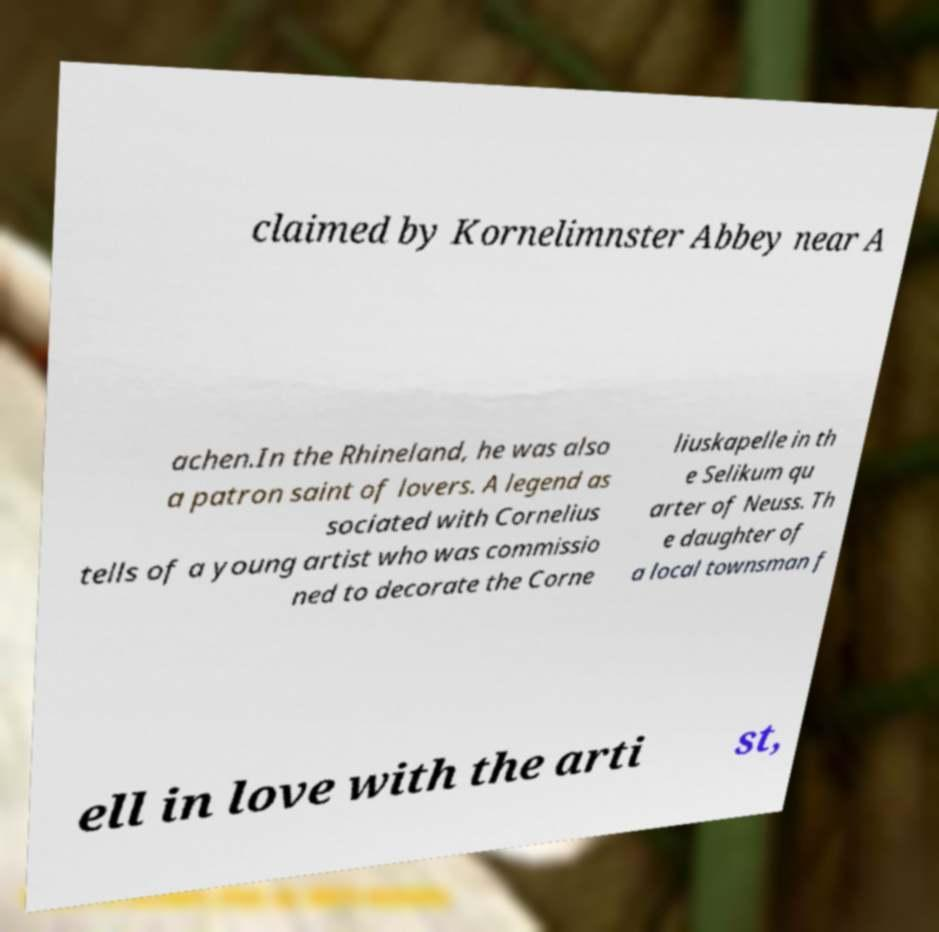I need the written content from this picture converted into text. Can you do that? claimed by Kornelimnster Abbey near A achen.In the Rhineland, he was also a patron saint of lovers. A legend as sociated with Cornelius tells of a young artist who was commissio ned to decorate the Corne liuskapelle in th e Selikum qu arter of Neuss. Th e daughter of a local townsman f ell in love with the arti st, 